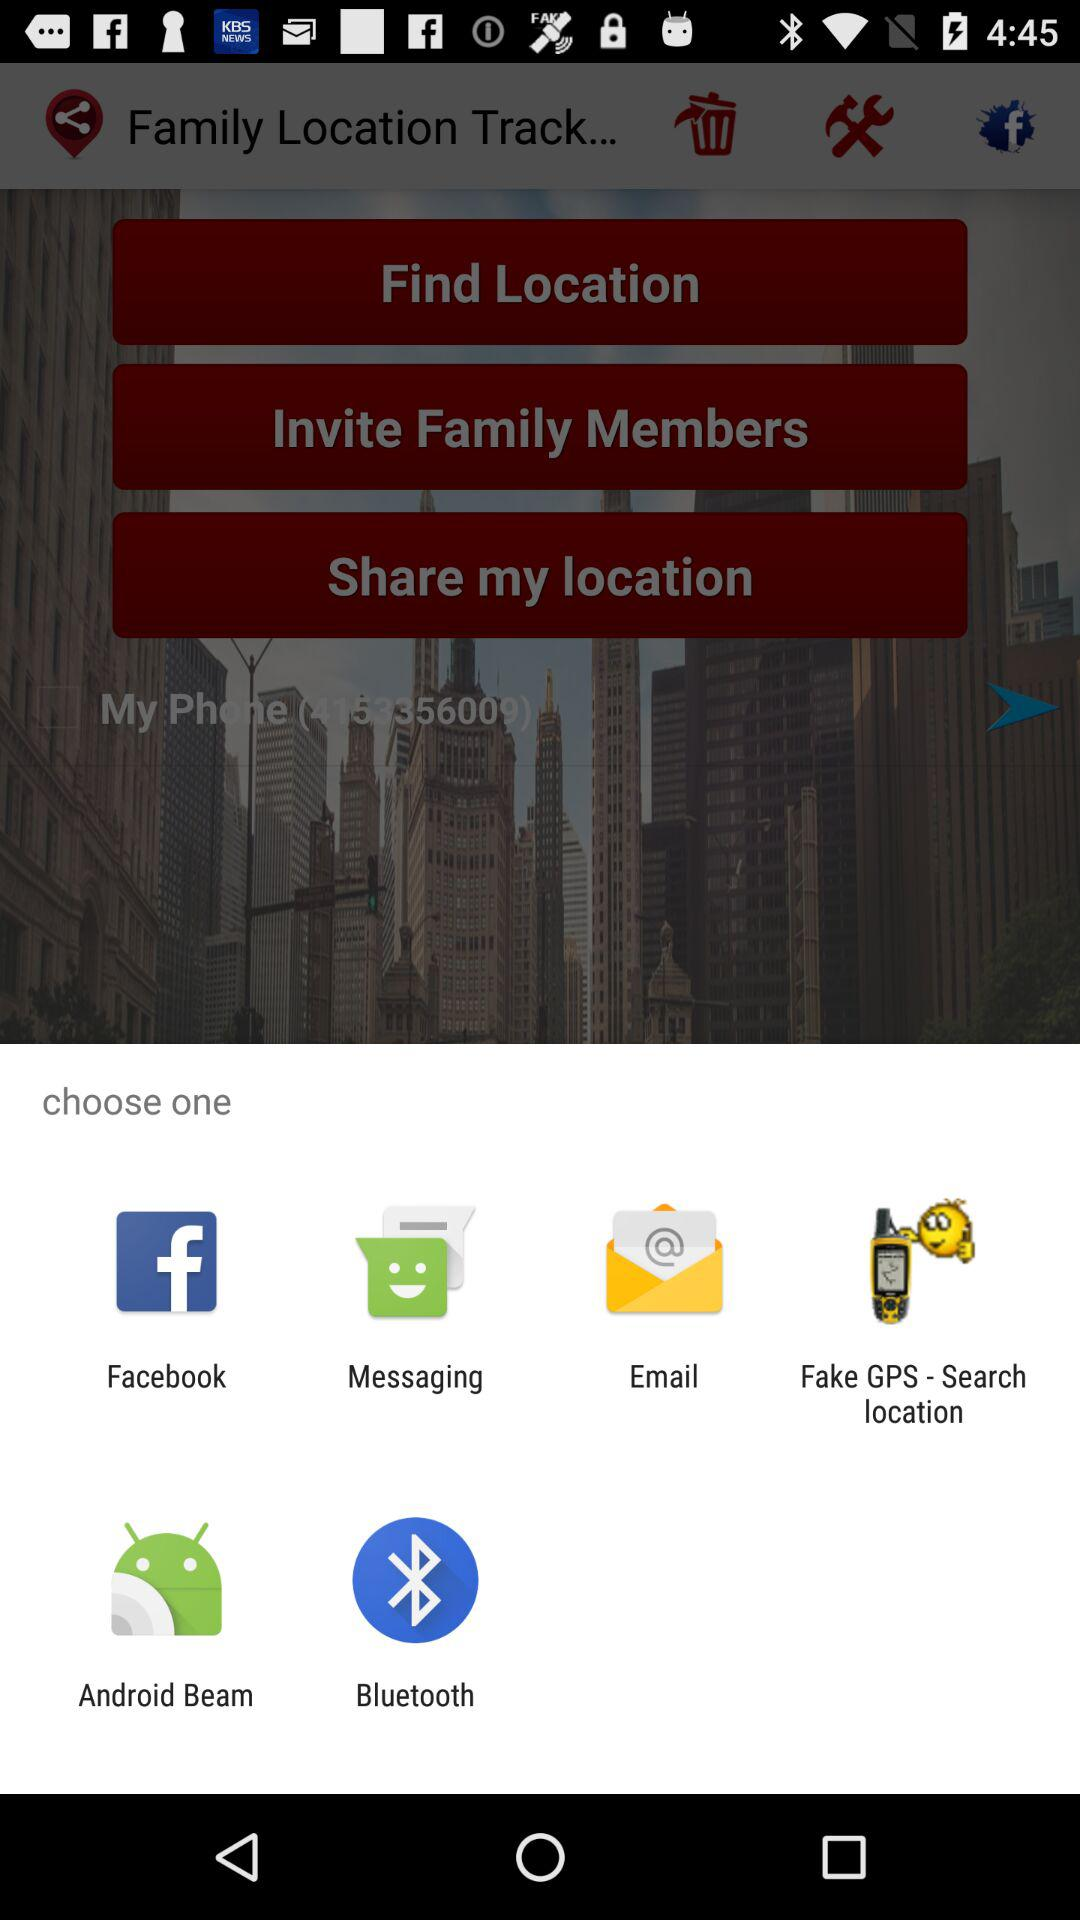What are the options to choose? The options to choose are "Facebook", "Messaging", "Email", "Fake GPS - Search location", "Android Beam" and "Bluetooth". 